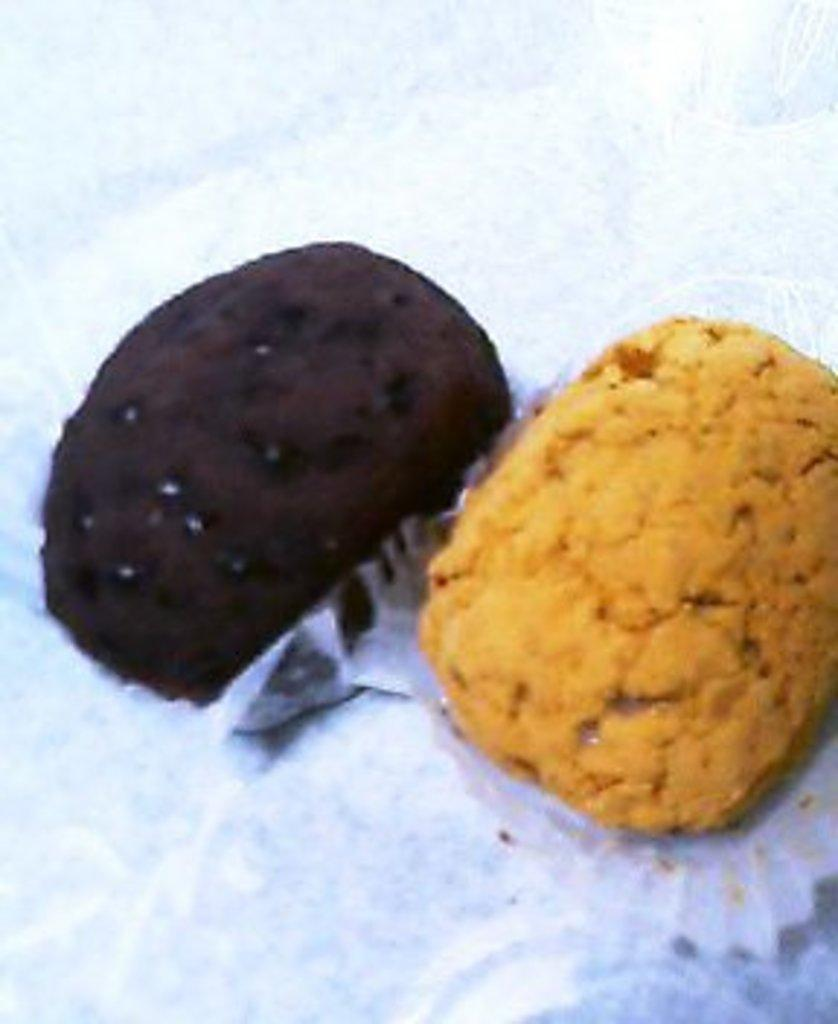How many cupcakes are visible in the image? There are two cupcakes in the image. Where are the cupcakes located? The cupcakes are on a platform. What color is the sock on the front of the cupcakes in the image? There is no sock present in the image, and the front of the cupcakes is not mentioned in the provided facts. 